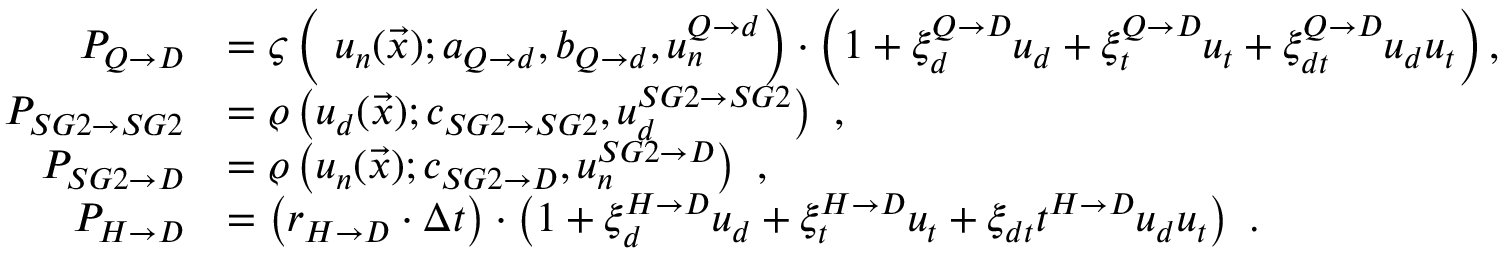<formula> <loc_0><loc_0><loc_500><loc_500>\begin{array} { r l } { P _ { Q \rightarrow D } } & { = \varsigma \left ( \ u _ { n } ( \vec { x } ) ; a _ { Q \rightarrow d } , b _ { Q \rightarrow d } , u _ { n } ^ { Q \rightarrow d } \right ) \cdot \left ( 1 + \xi _ { d } ^ { Q \rightarrow D } u _ { d } + \xi _ { t } ^ { Q \rightarrow D } u _ { t } + \xi _ { d t } ^ { Q \rightarrow D } u _ { d } u _ { t } \right ) , } \\ { P _ { S G 2 \rightarrow S G 2 } } & { = \varrho \left ( u _ { d } ( \vec { x } ) ; c _ { S G 2 \rightarrow S G 2 } , u _ { d } ^ { S G 2 \rightarrow S G 2 } \right ) \ , } \\ { P _ { S G 2 \rightarrow D } } & { = \varrho \left ( u _ { n } ( \vec { x } ) ; c _ { S G 2 \rightarrow D } , u _ { n } ^ { S G 2 \rightarrow D } \right ) \ , } \\ { P _ { H \rightarrow D } } & { = \left ( r _ { H \rightarrow D } \cdot \Delta t \right ) \cdot \left ( 1 + \xi _ { d } ^ { H \rightarrow D } u _ { d } + \xi _ { t } ^ { H \rightarrow D } u _ { t } + \xi _ { d t } t ^ { H \rightarrow D } u _ { d } u _ { t } \right ) \ . } \end{array}</formula> 